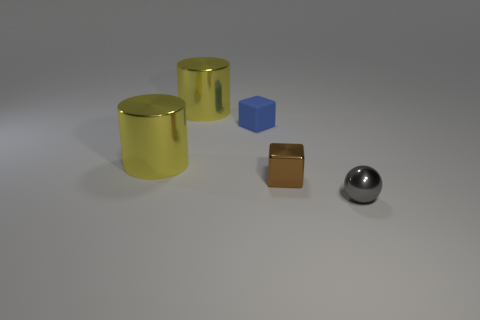Are there more small brown cubes than big red spheres?
Give a very brief answer. Yes. How many other matte cubes are the same color as the matte cube?
Your response must be concise. 0. The other tiny metallic object that is the same shape as the blue thing is what color?
Keep it short and to the point. Brown. What is the material of the thing that is in front of the small matte object and to the left of the blue thing?
Keep it short and to the point. Metal. Are the block right of the blue rubber object and the large yellow thing that is behind the rubber block made of the same material?
Provide a succinct answer. Yes. The gray metallic object has what size?
Make the answer very short. Small. There is a brown metal thing that is the same shape as the small matte object; what size is it?
Offer a very short reply. Small. How many shiny spheres are behind the tiny brown block?
Ensure brevity in your answer.  0. There is a large object that is on the left side of the large yellow object that is behind the small rubber object; what is its color?
Offer a very short reply. Yellow. Is there anything else that is the same shape as the tiny rubber object?
Your response must be concise. Yes. 